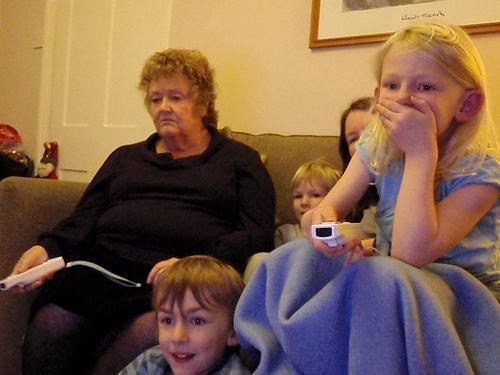How many people are here?
Give a very brief answer. 5. 